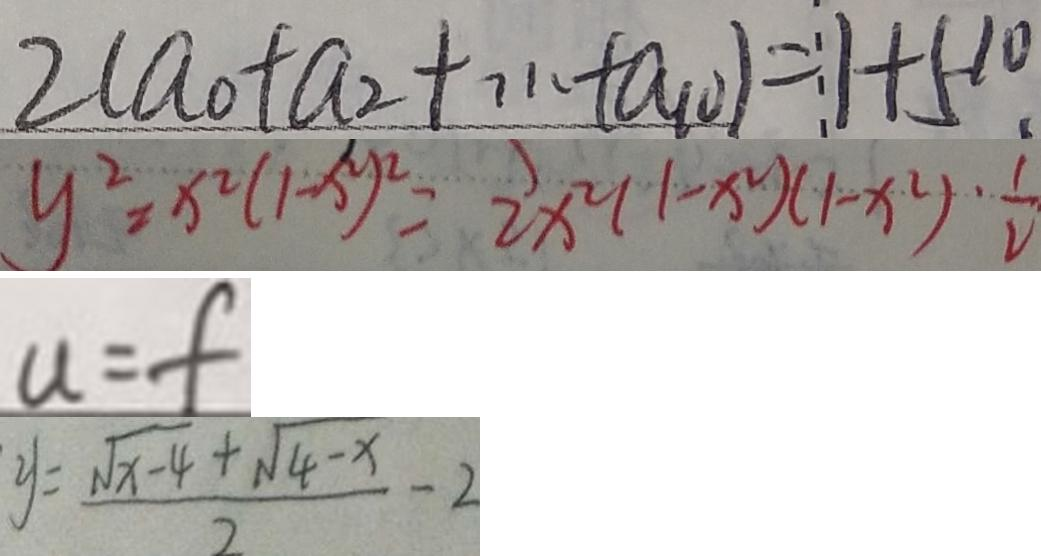Convert formula to latex. <formula><loc_0><loc_0><loc_500><loc_500>2 ( a _ { 0 } + a _ { 2 } + \cdots + a _ { 1 0 } ) = 1 + 5 ^ { 1 0 } . 
 y ^ { 2 } = x ^ { 2 } ( 1 - x ^ { 2 } ) ^ { 2 } = 2 x ^ { 2 } ( 1 - x ^ { 2 } ) ( 1 - x ^ { 2 } ) \cdot \frac { 1 } { 2 } 
 u = f 
 y = \frac { \sqrt { x - 4 } + \sqrt { 4 - x } } { 2 } - 2</formula> 